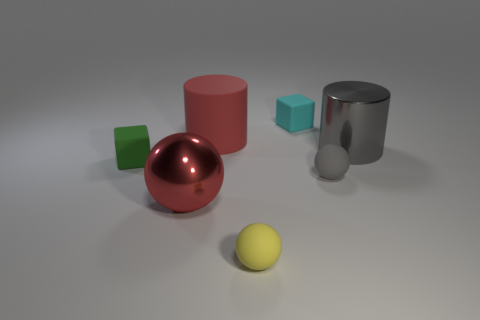What number of other objects are there of the same shape as the red metallic thing?
Your answer should be very brief. 2. Do the big sphere and the rubber cylinder have the same color?
Your answer should be compact. Yes. There is a matte object that is left of the small yellow matte thing and behind the large gray shiny object; what size is it?
Give a very brief answer. Large. Do the large object that is left of the big red matte cylinder and the large rubber object have the same color?
Your response must be concise. Yes. There is a small rubber object that is behind the tiny gray ball and in front of the cyan block; what shape is it?
Offer a terse response. Cube. Are any small purple metal blocks visible?
Make the answer very short. No. What is the material of the other big object that is the same shape as the red rubber thing?
Your response must be concise. Metal. What shape is the shiny thing to the right of the cylinder on the left side of the small rubber cube that is right of the tiny green block?
Offer a terse response. Cylinder. What material is the cylinder that is the same color as the large metal ball?
Provide a short and direct response. Rubber. How many other rubber objects have the same shape as the tiny yellow thing?
Your response must be concise. 1. 